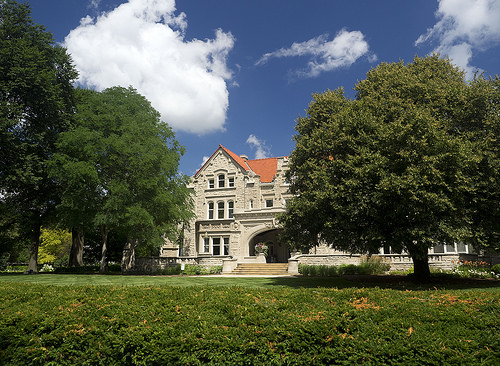<image>
Can you confirm if the house is behind the tree? Yes. From this viewpoint, the house is positioned behind the tree, with the tree partially or fully occluding the house. Is there a house in front of the grass? No. The house is not in front of the grass. The spatial positioning shows a different relationship between these objects. 